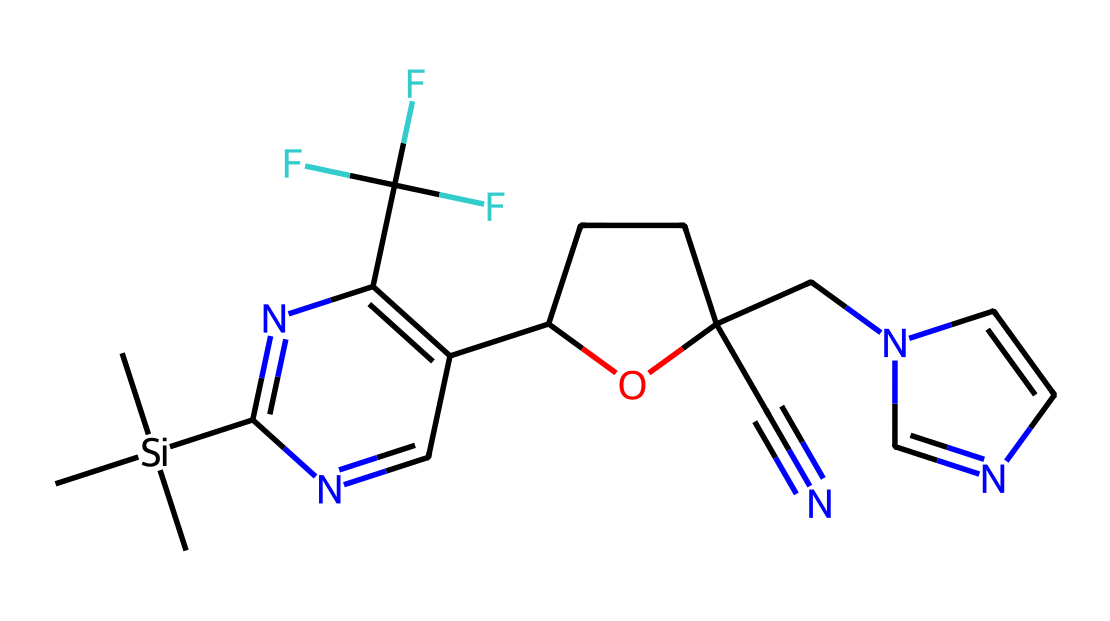What is the molecular formula of this compound? To determine the molecular formula, we need to count the number of each type of atom present in the structure. The structure contains silicon (Si), carbon (C), nitrogen (N), oxygen (O), and fluorine (F). By visualizing the SMILES representation, we identify there are 17 carbon atoms, 1 silicon atom, 3 nitrogen atoms, 1 oxygen atom, and 3 fluorine atoms. Thus, the molecular formula is C17H22F3N3OSi.
Answer: C17H22F3N3OSi How many rings are present in the structure? By analyzing the SMILES code and visualizing the structure, we can identify the number of cyclic components or rings. There are two numerical indicators (1 and 2) in the SMILES indicating the start and end of two ring structures. Therefore, there are 2 rings in total.
Answer: 2 What functional groups are present in the compound? We need to identify specific functional groups based on common structures found in the SMILES. The presence of a nitrogen atom connected to a carbon double bond signifies an imine, indicated by C=N. The presence of an –OH group suggests a hydroxyl functional group. Thus, the main functional groups present in the compound are imine and alcohol.
Answer: imine, alcohol Which element has the highest electronegativity in this structure? Examining the elements present, we consider their electronegativities: fluorine (F) has the highest electronegativity on the Pauling scale, followed by oxygen (O), then nitrogen (N), followed by carbon (C) and silicon (Si). Therefore, fluorine is the most electronegative element in the structure.
Answer: fluorine What type of hybridization is likely represented by the silicon atom? Silicon typically exhibits sp3 hybridization when it forms four single bonds, although in this type of compound, it may also show sp2 hybridization if involved in double bonding or coordinate covalent bonding (typically resulting from bonding with electronegative atoms). Evaluating the connections in the SMILES, the silicon atom forms bonds with three carbon atoms and is likely sp3 hybridized.
Answer: sp3 Which species in the compound contributes to its pesticidal properties? Pesticides often contain functional groups or elements that exhibit toxicity or biological activity. In this case, the presence of nitrogen species (e.g., CN or N=N linkages) hints at potential biological activity. The fluorine atoms could also enhance toxicity due to their strong electronegativity and ability to disrupt biological processes. Therefore, the nitrogen atoms and fluorine atoms mainly contribute to its pesticidal properties.
Answer: nitrogen and fluorine 